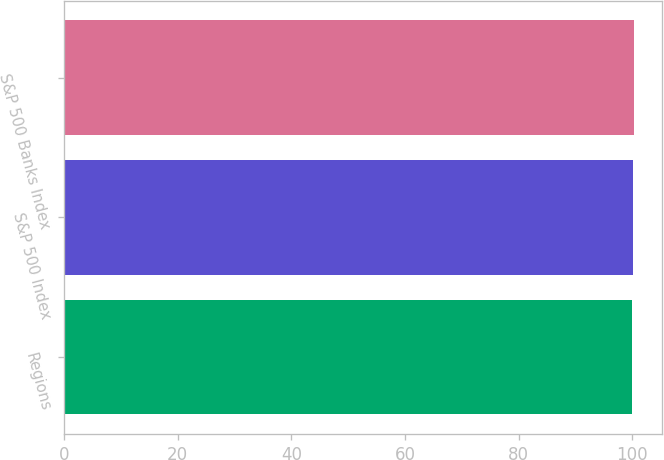Convert chart to OTSL. <chart><loc_0><loc_0><loc_500><loc_500><bar_chart><fcel>Regions<fcel>S&P 500 Index<fcel>S&P 500 Banks Index<nl><fcel>100<fcel>100.1<fcel>100.2<nl></chart> 